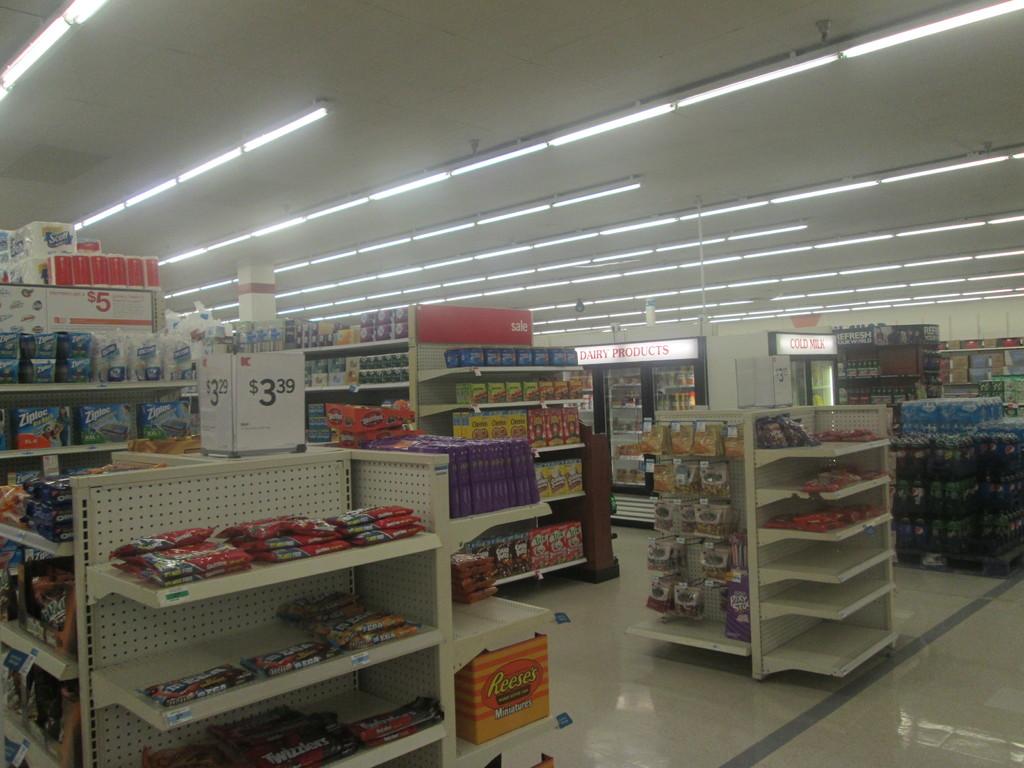What is the price on the shelf?
Give a very brief answer. 3.39. 